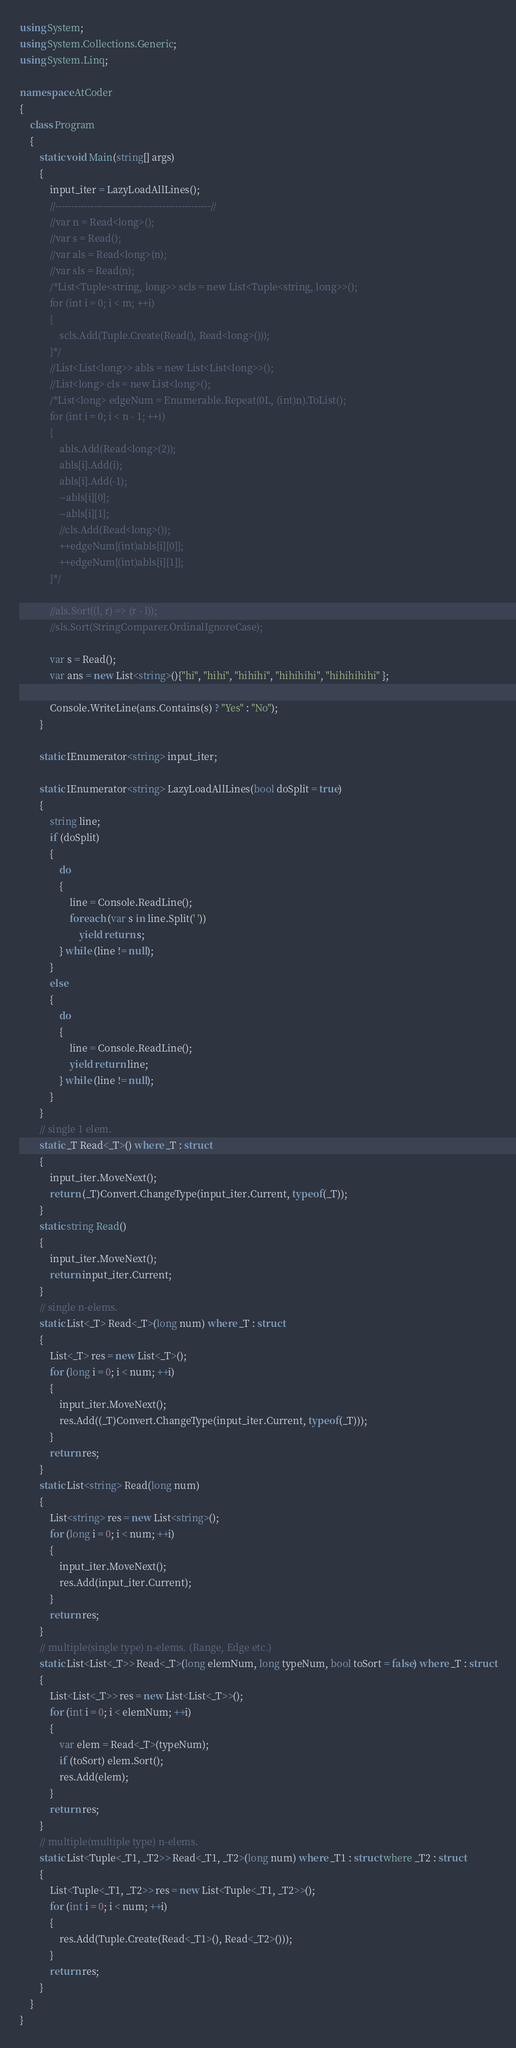Convert code to text. <code><loc_0><loc_0><loc_500><loc_500><_C#_>using System;
using System.Collections.Generic;
using System.Linq;

namespace AtCoder
{
    class Program
    {
        static void Main(string[] args)
        {
            input_iter = LazyLoadAllLines();
            //------------------------------------------------//
            //var n = Read<long>();
            //var s = Read();
            //var als = Read<long>(n);
            //var sls = Read(n);
            /*List<Tuple<string, long>> scls = new List<Tuple<string, long>>();
            for (int i = 0; i < m; ++i)
            {
                scls.Add(Tuple.Create(Read(), Read<long>()));
            }*/
            //List<List<long>> abls = new List<List<long>>();
            //List<long> cls = new List<long>();
            /*List<long> edgeNum = Enumerable.Repeat(0L, (int)n).ToList();
            for (int i = 0; i < n - 1; ++i)
            {
                abls.Add(Read<long>(2));
                abls[i].Add(i);
                abls[i].Add(-1);
                --abls[i][0];
                --abls[i][1];
                //cls.Add(Read<long>());
                ++edgeNum[(int)abls[i][0]];
                ++edgeNum[(int)abls[i][1]];
            }*/

            //als.Sort((l, r) => (r - l));
            //sls.Sort(StringComparer.OrdinalIgnoreCase);

            var s = Read();
            var ans = new List<string>(){"hi", "hihi", "hihihi", "hihihihi", "hihihihihi" };

            Console.WriteLine(ans.Contains(s) ? "Yes" : "No");
        }

        static IEnumerator<string> input_iter;

        static IEnumerator<string> LazyLoadAllLines(bool doSplit = true)
        {
            string line;
            if (doSplit)
            {
                do
                {
                    line = Console.ReadLine();
                    foreach (var s in line.Split(' '))
                        yield return s;
                } while (line != null);
            }
            else
            {
                do
                {
                    line = Console.ReadLine();
                    yield return line;
                } while (line != null);
            }
        }
        // single 1 elem.
        static _T Read<_T>() where _T : struct
        {
            input_iter.MoveNext();
            return (_T)Convert.ChangeType(input_iter.Current, typeof(_T));
        }
        static string Read()
        {
            input_iter.MoveNext();
            return input_iter.Current;
        }
        // single n-elems.
        static List<_T> Read<_T>(long num) where _T : struct
        {
            List<_T> res = new List<_T>();
            for (long i = 0; i < num; ++i)
            {
                input_iter.MoveNext();
                res.Add((_T)Convert.ChangeType(input_iter.Current, typeof(_T)));
            }
            return res;
        }
        static List<string> Read(long num)
        {
            List<string> res = new List<string>();
            for (long i = 0; i < num; ++i)
            {
                input_iter.MoveNext();
                res.Add(input_iter.Current);
            }
            return res;
        }
        // multiple(single type) n-elems. (Range, Edge etc.)
        static List<List<_T>> Read<_T>(long elemNum, long typeNum, bool toSort = false) where _T : struct
        {
            List<List<_T>> res = new List<List<_T>>();
            for (int i = 0; i < elemNum; ++i)
            {
                var elem = Read<_T>(typeNum);
                if (toSort) elem.Sort();
                res.Add(elem);
            }
            return res;
        }
        // multiple(multiple type) n-elems.
        static List<Tuple<_T1, _T2>> Read<_T1, _T2>(long num) where _T1 : struct where _T2 : struct
        {
            List<Tuple<_T1, _T2>> res = new List<Tuple<_T1, _T2>>();
            for (int i = 0; i < num; ++i)
            {
                res.Add(Tuple.Create(Read<_T1>(), Read<_T2>()));
            }
            return res;
        }
    }
}
</code> 